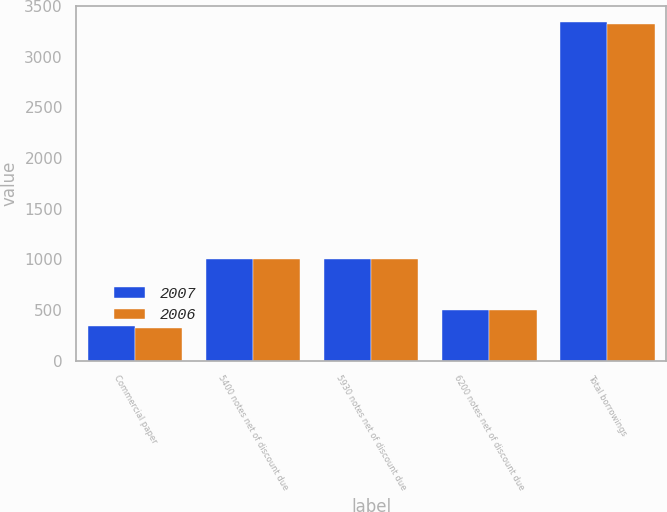Convert chart. <chart><loc_0><loc_0><loc_500><loc_500><stacked_bar_chart><ecel><fcel>Commercial paper<fcel>5400 notes net of discount due<fcel>5930 notes net of discount due<fcel>6200 notes net of discount due<fcel>Total borrowings<nl><fcel>2007<fcel>338.2<fcel>1002.8<fcel>999.7<fcel>497.3<fcel>3338<nl><fcel>2006<fcel>324.6<fcel>999<fcel>999.7<fcel>497.2<fcel>3323.5<nl></chart> 